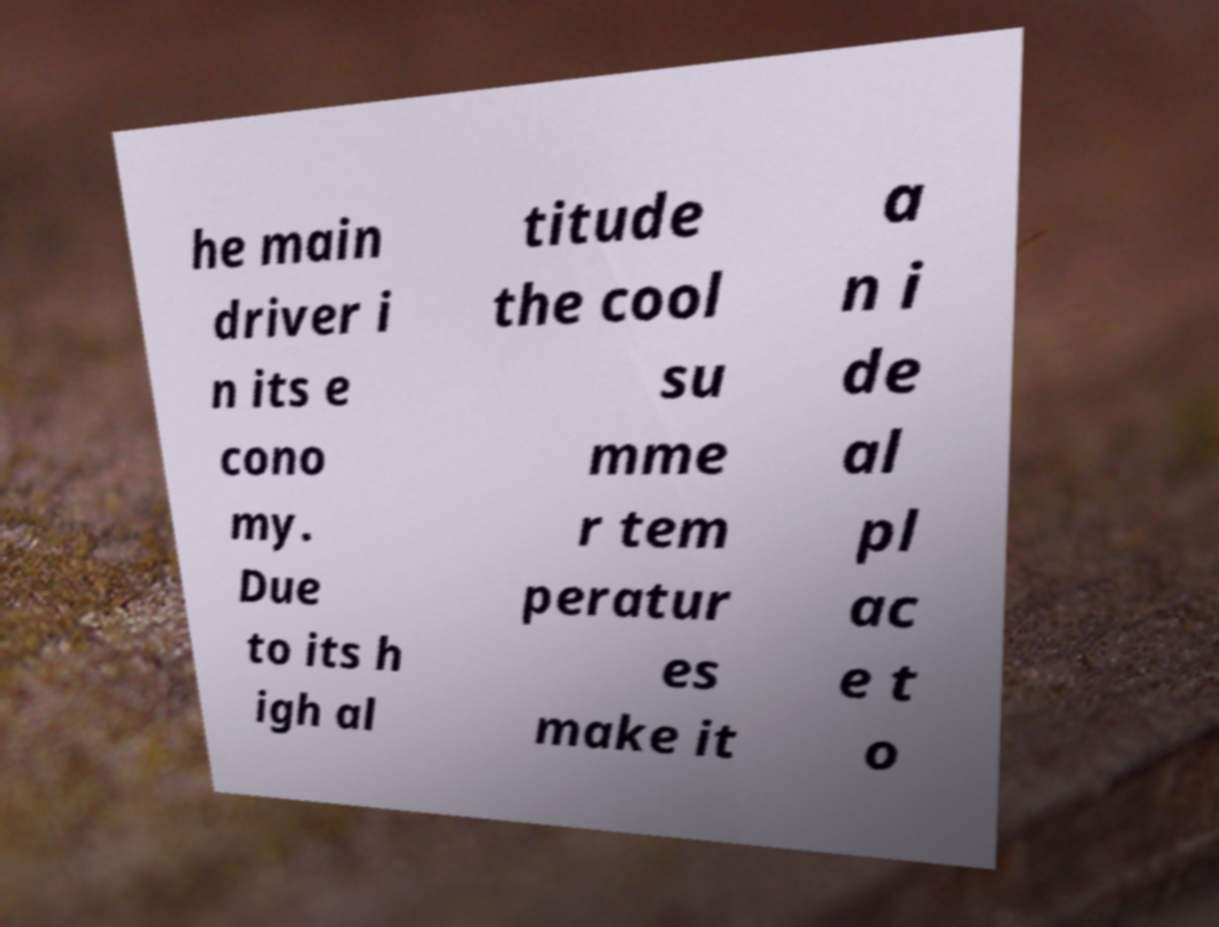Can you accurately transcribe the text from the provided image for me? he main driver i n its e cono my. Due to its h igh al titude the cool su mme r tem peratur es make it a n i de al pl ac e t o 